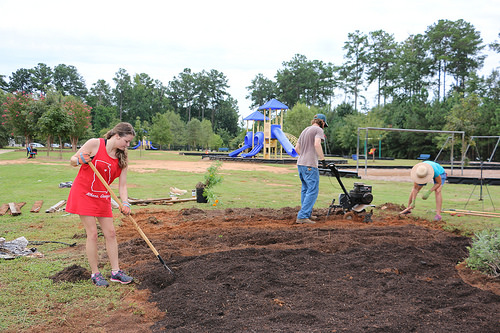<image>
Is the tree behind the woman? Yes. From this viewpoint, the tree is positioned behind the woman, with the woman partially or fully occluding the tree. Is there a man behind the plant? No. The man is not behind the plant. From this viewpoint, the man appears to be positioned elsewhere in the scene. 